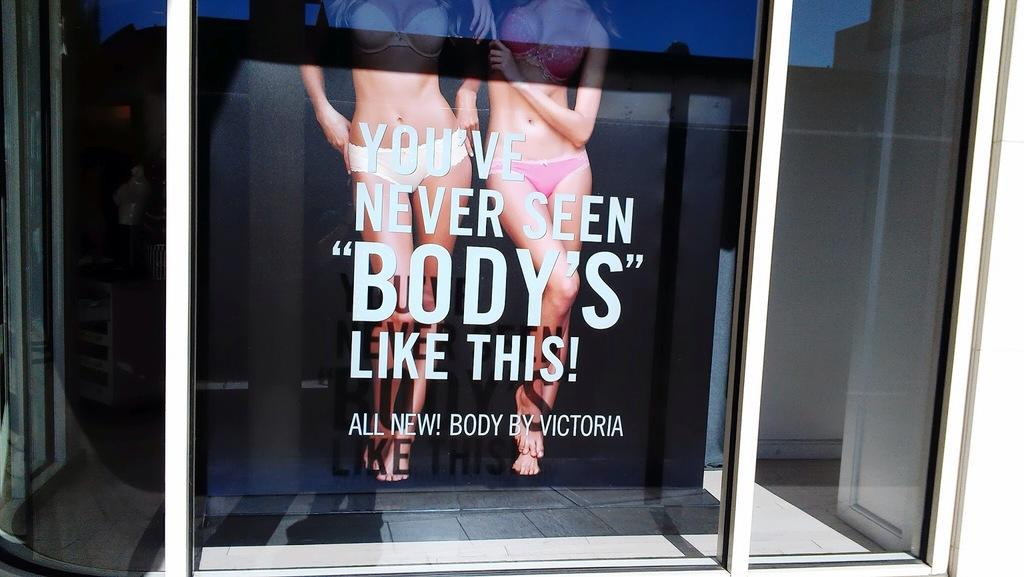What type of objects are present in the image? There are glass objects in the image. Can you describe any specific details about the glass objects? One of the glass objects has text on it. What can be seen through the glass object? A banner is visible through the glass object. What is the surface that the glass objects are resting on? There is a floor at the bottom of the image. How many boats are visible in the image? There are no boats present in the image. What type of peace symbol can be seen on the glass objects? There is no peace symbol present on the glass objects in the image. 